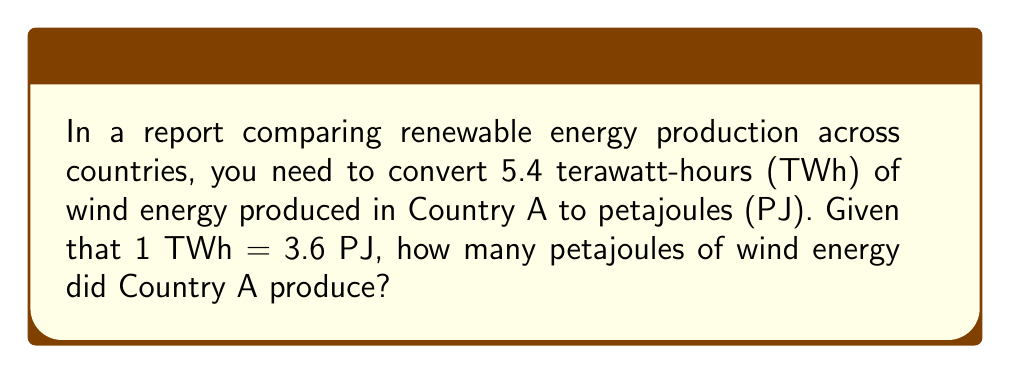Can you solve this math problem? To solve this problem, we need to convert terawatt-hours (TWh) to petajoules (PJ) using the given conversion factor. Let's break it down step-by-step:

1. Identify the given information:
   - Country A produced 5.4 TWh of wind energy
   - Conversion factor: 1 TWh = 3.6 PJ

2. Set up the conversion equation:
   $$ x \text{ PJ} = 5.4 \text{ TWh} \times \frac{3.6 \text{ PJ}}{1 \text{ TWh}} $$

3. Calculate the result:
   $$ x \text{ PJ} = 5.4 \times 3.6 \text{ PJ} $$
   $$ x \text{ PJ} = 19.44 \text{ PJ} $$

Therefore, Country A produced 19.44 petajoules of wind energy.
Answer: 19.44 PJ 